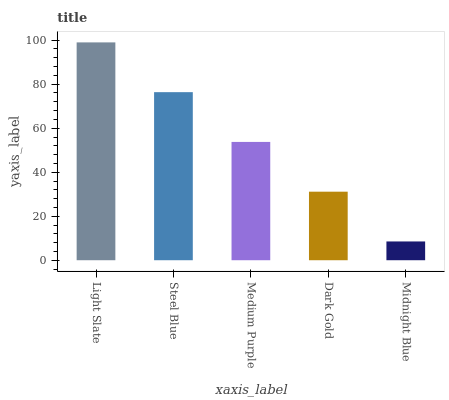Is Midnight Blue the minimum?
Answer yes or no. Yes. Is Light Slate the maximum?
Answer yes or no. Yes. Is Steel Blue the minimum?
Answer yes or no. No. Is Steel Blue the maximum?
Answer yes or no. No. Is Light Slate greater than Steel Blue?
Answer yes or no. Yes. Is Steel Blue less than Light Slate?
Answer yes or no. Yes. Is Steel Blue greater than Light Slate?
Answer yes or no. No. Is Light Slate less than Steel Blue?
Answer yes or no. No. Is Medium Purple the high median?
Answer yes or no. Yes. Is Medium Purple the low median?
Answer yes or no. Yes. Is Dark Gold the high median?
Answer yes or no. No. Is Dark Gold the low median?
Answer yes or no. No. 